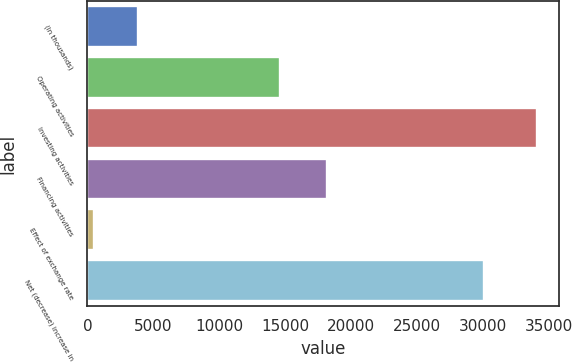Convert chart to OTSL. <chart><loc_0><loc_0><loc_500><loc_500><bar_chart><fcel>(In thousands)<fcel>Operating activities<fcel>Investing activities<fcel>Financing activities<fcel>Effect of exchange rate<fcel>Net (decrease) increase in<nl><fcel>3855.7<fcel>14628<fcel>34084<fcel>18148<fcel>497<fcel>30067<nl></chart> 